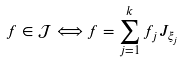<formula> <loc_0><loc_0><loc_500><loc_500>f \in \mathcal { J } \Longleftrightarrow f = \sum _ { j = 1 } ^ { k } f _ { j } J _ { \xi _ { j } }</formula> 